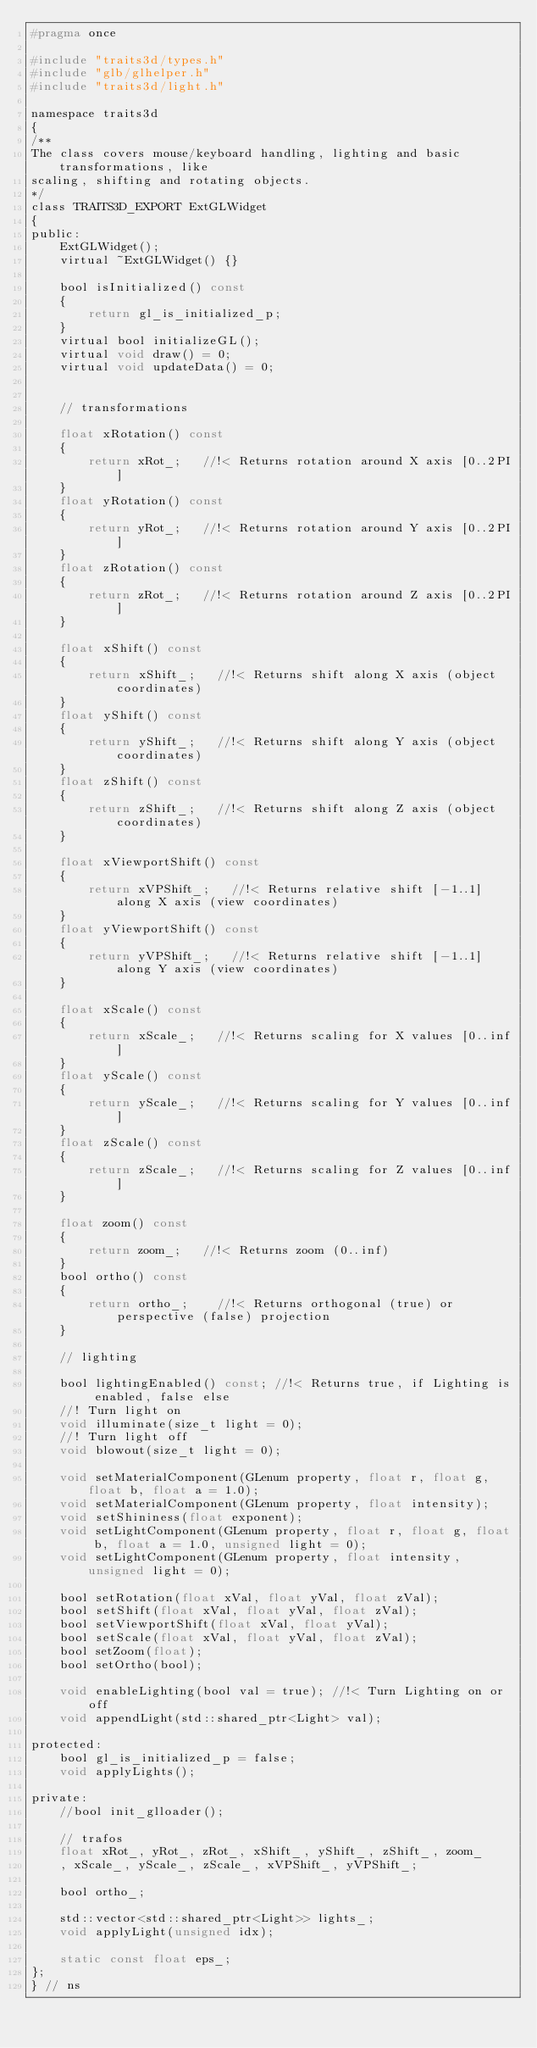<code> <loc_0><loc_0><loc_500><loc_500><_C_>#pragma once

#include "traits3d/types.h"
#include "glb/glhelper.h"
#include "traits3d/light.h"

namespace traits3d
{
/**
The class covers mouse/keyboard handling, lighting and basic transformations, like
scaling, shifting and rotating objects.
*/
class TRAITS3D_EXPORT ExtGLWidget
{
public:
    ExtGLWidget();
    virtual ~ExtGLWidget() {}

    bool isInitialized() const
    {
        return gl_is_initialized_p;
    }
    virtual bool initializeGL();
    virtual void draw() = 0;
    virtual void updateData() = 0;


    // transformations

    float xRotation() const
    {
        return xRot_;   //!< Returns rotation around X axis [0..2PI]
    }
    float yRotation() const
    {
        return yRot_;   //!< Returns rotation around Y axis [0..2PI]
    }
    float zRotation() const
    {
        return zRot_;   //!< Returns rotation around Z axis [0..2PI]
    }

    float xShift() const
    {
        return xShift_;   //!< Returns shift along X axis (object coordinates)
    }
    float yShift() const
    {
        return yShift_;   //!< Returns shift along Y axis (object coordinates)
    }
    float zShift() const
    {
        return zShift_;   //!< Returns shift along Z axis (object coordinates)
    }

    float xViewportShift() const
    {
        return xVPShift_;   //!< Returns relative shift [-1..1] along X axis (view coordinates)
    }
    float yViewportShift() const
    {
        return yVPShift_;   //!< Returns relative shift [-1..1] along Y axis (view coordinates)
    }

    float xScale() const
    {
        return xScale_;   //!< Returns scaling for X values [0..inf]
    }
    float yScale() const
    {
        return yScale_;   //!< Returns scaling for Y values [0..inf]
    }
    float zScale() const
    {
        return zScale_;   //!< Returns scaling for Z values [0..inf]
    }

    float zoom() const
    {
        return zoom_;   //!< Returns zoom (0..inf)
    }
    bool ortho() const
    {
        return ortho_;    //!< Returns orthogonal (true) or perspective (false) projection
    }

    // lighting

    bool lightingEnabled() const; //!< Returns true, if Lighting is enabled, false else
    //! Turn light on
    void illuminate(size_t light = 0);
    //! Turn light off
    void blowout(size_t light = 0);

    void setMaterialComponent(GLenum property, float r, float g, float b, float a = 1.0);
    void setMaterialComponent(GLenum property, float intensity);
    void setShininess(float exponent);
    void setLightComponent(GLenum property, float r, float g, float b, float a = 1.0, unsigned light = 0);
    void setLightComponent(GLenum property, float intensity, unsigned light = 0);

    bool setRotation(float xVal, float yVal, float zVal);
    bool setShift(float xVal, float yVal, float zVal);
    bool setViewportShift(float xVal, float yVal);
    bool setScale(float xVal, float yVal, float zVal);
    bool setZoom(float);
    bool setOrtho(bool);

    void enableLighting(bool val = true); //!< Turn Lighting on or off
    void appendLight(std::shared_ptr<Light> val);

protected:
    bool gl_is_initialized_p = false;
    void applyLights();

private:
    //bool init_glloader();

    // trafos
    float xRot_, yRot_, zRot_, xShift_, yShift_, zShift_, zoom_
    , xScale_, yScale_, zScale_, xVPShift_, yVPShift_;

    bool ortho_;

    std::vector<std::shared_ptr<Light>> lights_;
    void applyLight(unsigned idx);

    static const float eps_;
};
} // ns


</code> 